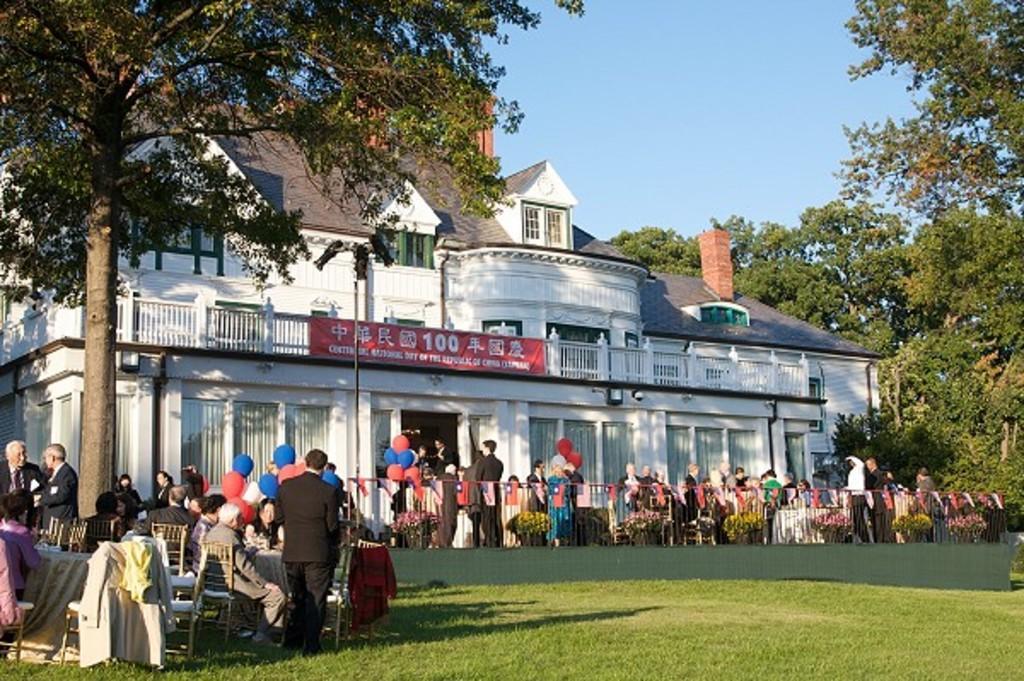Could you give a brief overview of what you see in this image? In this picture we can see a building, in front of the building we can see some people are sitting on the chairs, in front of them we can see some tables, few people are standing, some balloon are tied to the fencing, around we can see some trees and grass.. 